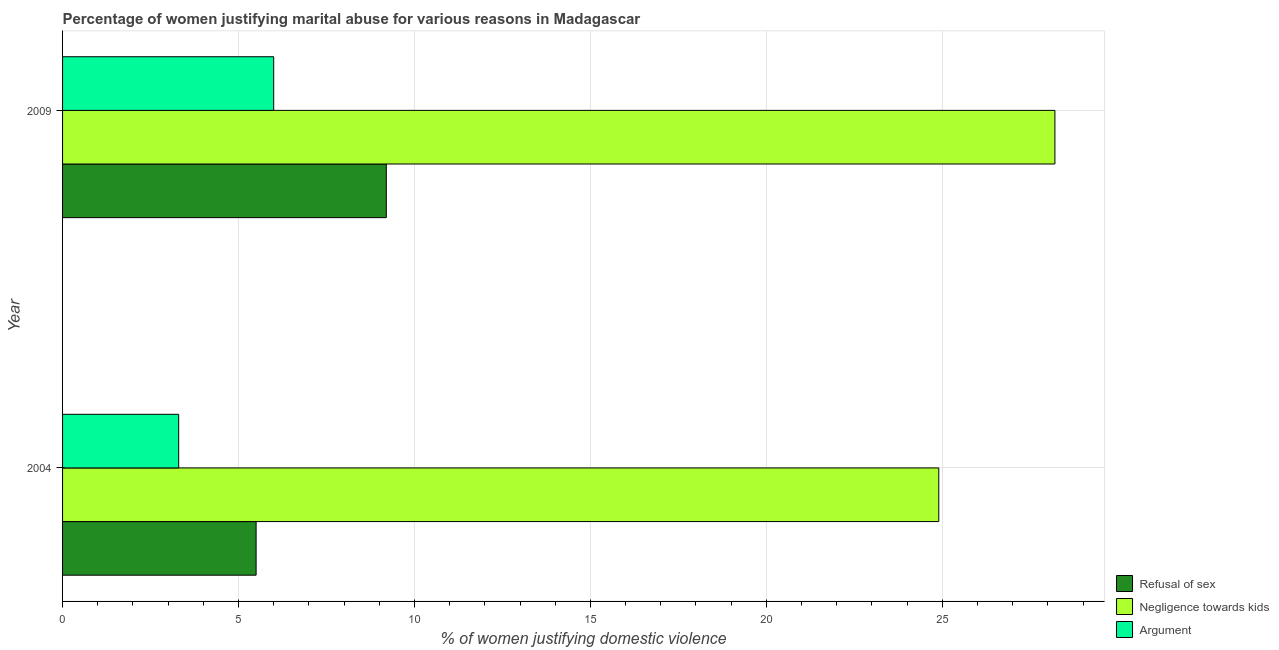Are the number of bars per tick equal to the number of legend labels?
Ensure brevity in your answer.  Yes. What is the percentage of women justifying domestic violence due to refusal of sex in 2009?
Offer a very short reply. 9.2. Across all years, what is the maximum percentage of women justifying domestic violence due to negligence towards kids?
Your response must be concise. 28.2. Across all years, what is the minimum percentage of women justifying domestic violence due to negligence towards kids?
Give a very brief answer. 24.9. In which year was the percentage of women justifying domestic violence due to refusal of sex minimum?
Your response must be concise. 2004. What is the total percentage of women justifying domestic violence due to refusal of sex in the graph?
Offer a terse response. 14.7. What is the difference between the percentage of women justifying domestic violence due to negligence towards kids in 2009 and the percentage of women justifying domestic violence due to refusal of sex in 2004?
Your answer should be very brief. 22.7. What is the average percentage of women justifying domestic violence due to arguments per year?
Offer a very short reply. 4.65. In the year 2004, what is the difference between the percentage of women justifying domestic violence due to negligence towards kids and percentage of women justifying domestic violence due to refusal of sex?
Give a very brief answer. 19.4. In how many years, is the percentage of women justifying domestic violence due to arguments greater than 4 %?
Offer a very short reply. 1. What is the ratio of the percentage of women justifying domestic violence due to arguments in 2004 to that in 2009?
Make the answer very short. 0.55. What does the 2nd bar from the top in 2004 represents?
Keep it short and to the point. Negligence towards kids. What does the 1st bar from the bottom in 2009 represents?
Provide a succinct answer. Refusal of sex. Is it the case that in every year, the sum of the percentage of women justifying domestic violence due to refusal of sex and percentage of women justifying domestic violence due to negligence towards kids is greater than the percentage of women justifying domestic violence due to arguments?
Your answer should be compact. Yes. How many bars are there?
Provide a succinct answer. 6. How many years are there in the graph?
Ensure brevity in your answer.  2. What is the difference between two consecutive major ticks on the X-axis?
Your response must be concise. 5. Does the graph contain any zero values?
Your answer should be very brief. No. Does the graph contain grids?
Your answer should be very brief. Yes. Where does the legend appear in the graph?
Your answer should be very brief. Bottom right. What is the title of the graph?
Make the answer very short. Percentage of women justifying marital abuse for various reasons in Madagascar. Does "Tertiary education" appear as one of the legend labels in the graph?
Your response must be concise. No. What is the label or title of the X-axis?
Provide a short and direct response. % of women justifying domestic violence. What is the % of women justifying domestic violence in Negligence towards kids in 2004?
Ensure brevity in your answer.  24.9. What is the % of women justifying domestic violence of Argument in 2004?
Keep it short and to the point. 3.3. What is the % of women justifying domestic violence of Refusal of sex in 2009?
Make the answer very short. 9.2. What is the % of women justifying domestic violence in Negligence towards kids in 2009?
Offer a terse response. 28.2. Across all years, what is the maximum % of women justifying domestic violence of Refusal of sex?
Provide a succinct answer. 9.2. Across all years, what is the maximum % of women justifying domestic violence in Negligence towards kids?
Offer a terse response. 28.2. Across all years, what is the maximum % of women justifying domestic violence of Argument?
Your response must be concise. 6. Across all years, what is the minimum % of women justifying domestic violence in Refusal of sex?
Ensure brevity in your answer.  5.5. Across all years, what is the minimum % of women justifying domestic violence in Negligence towards kids?
Provide a succinct answer. 24.9. What is the total % of women justifying domestic violence of Refusal of sex in the graph?
Make the answer very short. 14.7. What is the total % of women justifying domestic violence in Negligence towards kids in the graph?
Provide a succinct answer. 53.1. What is the difference between the % of women justifying domestic violence in Argument in 2004 and that in 2009?
Your answer should be compact. -2.7. What is the difference between the % of women justifying domestic violence in Refusal of sex in 2004 and the % of women justifying domestic violence in Negligence towards kids in 2009?
Your response must be concise. -22.7. What is the difference between the % of women justifying domestic violence in Refusal of sex in 2004 and the % of women justifying domestic violence in Argument in 2009?
Offer a very short reply. -0.5. What is the average % of women justifying domestic violence of Refusal of sex per year?
Offer a terse response. 7.35. What is the average % of women justifying domestic violence of Negligence towards kids per year?
Your response must be concise. 26.55. What is the average % of women justifying domestic violence of Argument per year?
Provide a short and direct response. 4.65. In the year 2004, what is the difference between the % of women justifying domestic violence in Refusal of sex and % of women justifying domestic violence in Negligence towards kids?
Provide a short and direct response. -19.4. In the year 2004, what is the difference between the % of women justifying domestic violence in Negligence towards kids and % of women justifying domestic violence in Argument?
Provide a succinct answer. 21.6. In the year 2009, what is the difference between the % of women justifying domestic violence in Refusal of sex and % of women justifying domestic violence in Negligence towards kids?
Ensure brevity in your answer.  -19. In the year 2009, what is the difference between the % of women justifying domestic violence in Refusal of sex and % of women justifying domestic violence in Argument?
Make the answer very short. 3.2. In the year 2009, what is the difference between the % of women justifying domestic violence in Negligence towards kids and % of women justifying domestic violence in Argument?
Ensure brevity in your answer.  22.2. What is the ratio of the % of women justifying domestic violence of Refusal of sex in 2004 to that in 2009?
Your answer should be very brief. 0.6. What is the ratio of the % of women justifying domestic violence of Negligence towards kids in 2004 to that in 2009?
Make the answer very short. 0.88. What is the ratio of the % of women justifying domestic violence of Argument in 2004 to that in 2009?
Provide a succinct answer. 0.55. What is the difference between the highest and the second highest % of women justifying domestic violence in Refusal of sex?
Make the answer very short. 3.7. What is the difference between the highest and the second highest % of women justifying domestic violence in Negligence towards kids?
Make the answer very short. 3.3. What is the difference between the highest and the lowest % of women justifying domestic violence in Refusal of sex?
Offer a terse response. 3.7. What is the difference between the highest and the lowest % of women justifying domestic violence in Negligence towards kids?
Your response must be concise. 3.3. 